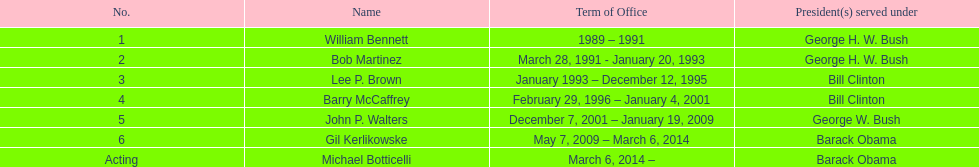What was the length of the first director's service in office? 2 years. 